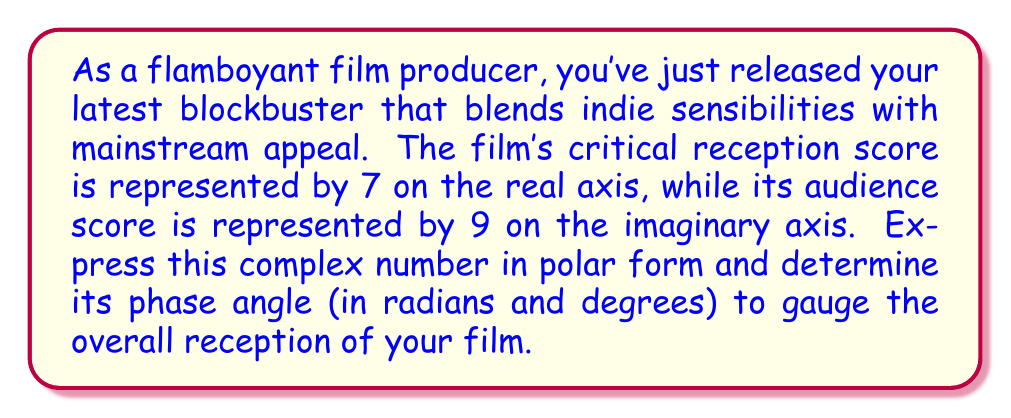Solve this math problem. Let's approach this step-by-step:

1) The complex number representing the film's reception is $z = 7 + 9i$.

2) To convert this to polar form, we need to find the modulus (r) and the phase angle (θ).

3) The modulus is calculated using the Pythagorean theorem:
   $$r = \sqrt{a^2 + b^2} = \sqrt{7^2 + 9^2} = \sqrt{130}$$

4) The phase angle θ is calculated using the arctangent function:
   $$\theta = \tan^{-1}\left(\frac{b}{a}\right) = \tan^{-1}\left(\frac{9}{7}\right)$$

5) Using a calculator or mathematical software:
   $$\theta \approx 0.9097 \text{ radians}$$

6) To convert radians to degrees, multiply by $\frac{180°}{\pi}$:
   $$\theta \approx 0.9097 \times \frac{180°}{\pi} \approx 52.13°$$

7) Therefore, the complex number in polar form is:
   $$z = \sqrt{130} (\cos(0.9097) + i \sin(0.9097))$$
   or
   $$z = \sqrt{130} e^{0.9097i}$$

The phase angle represents the balance between critical reception and audience score. An angle closer to 0° would indicate stronger critical reception, while an angle closer to 90° would indicate stronger audience reception.
Answer: The phase angle is approximately 0.9097 radians or 52.13°. 